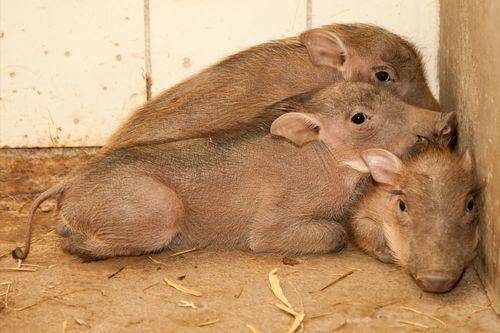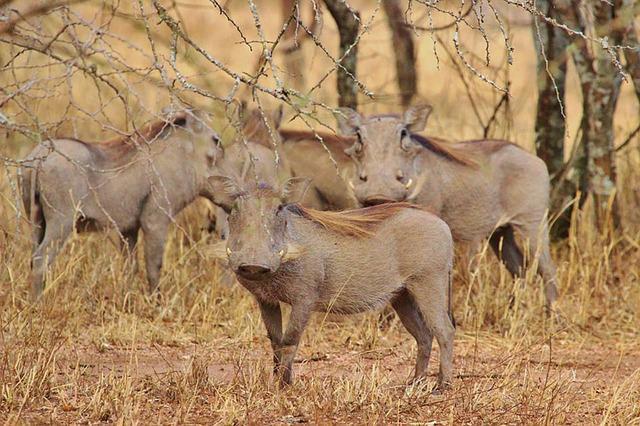The first image is the image on the left, the second image is the image on the right. Analyze the images presented: Is the assertion "Some baby pigs are cuddling near a wall." valid? Answer yes or no. Yes. The first image is the image on the left, the second image is the image on the right. Considering the images on both sides, is "There are at least two piglets lying down." valid? Answer yes or no. Yes. 